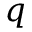<formula> <loc_0><loc_0><loc_500><loc_500>q</formula> 